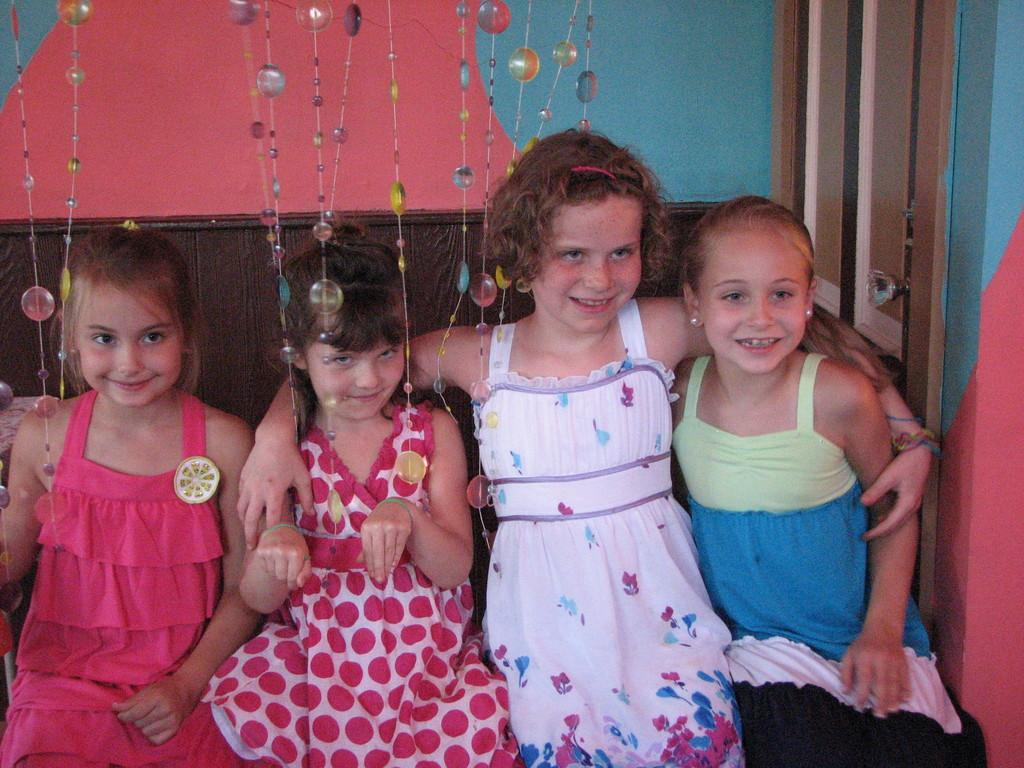What is the main subject of the image? The main subject of the image is a group of children. What are the children doing in the image? The children are sitting and smiling. What can be seen hanging in the image? There are hangings visible in the image. What type of architectural feature can be seen in the background of the image? There is a wall in the background of the image. What is another feature of the room visible in the image? There is a door in the image. Can you tell me how many flies are buzzing around the children in the image? There are no flies visible in the image; the focus is on the children and their surroundings. 